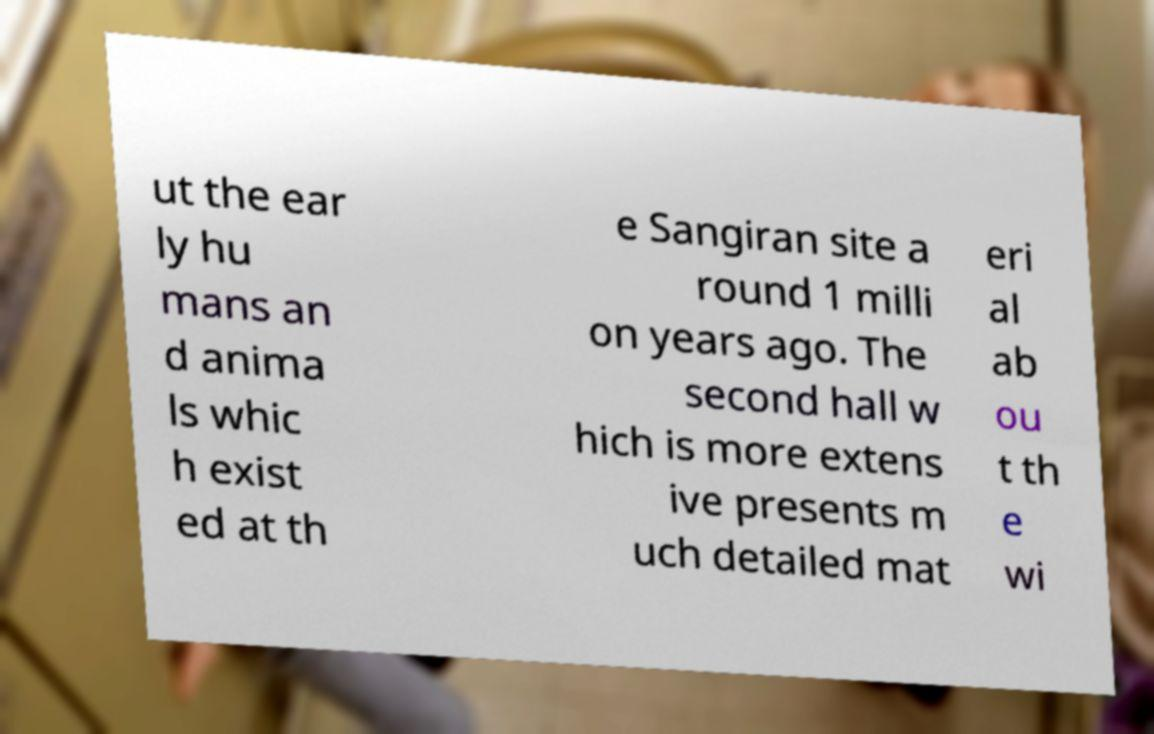Please identify and transcribe the text found in this image. ut the ear ly hu mans an d anima ls whic h exist ed at th e Sangiran site a round 1 milli on years ago. The second hall w hich is more extens ive presents m uch detailed mat eri al ab ou t th e wi 